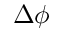<formula> <loc_0><loc_0><loc_500><loc_500>\Delta \phi</formula> 